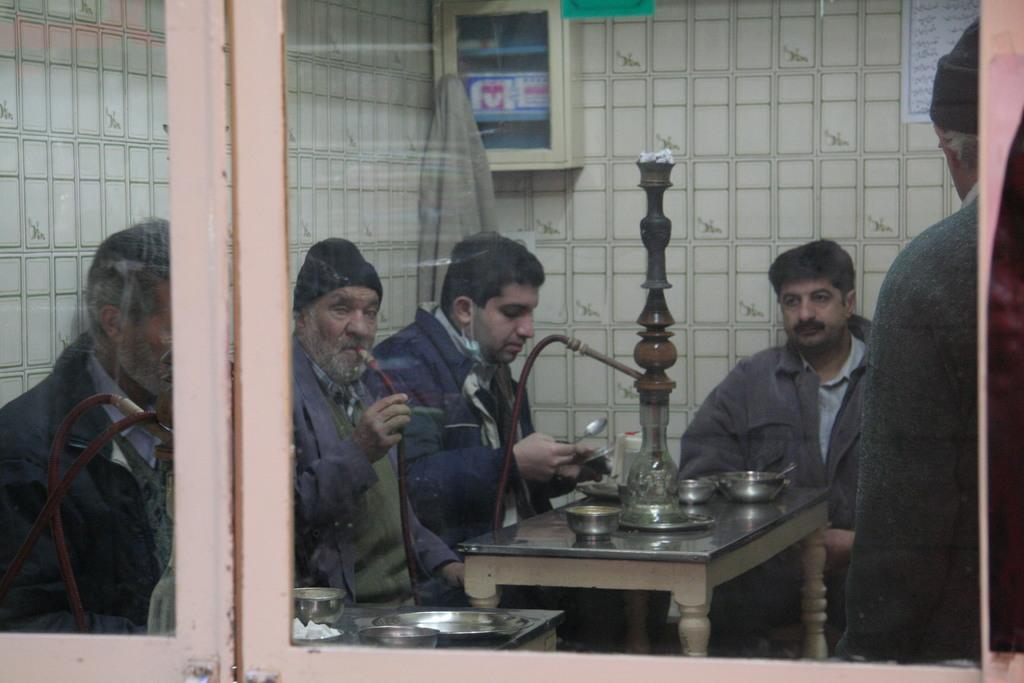What are the people in the image doing? There is a group of people sitting in chairs. What is on the table in front of the group of people? The table has a hookah pot on it. Is there anyone standing in the image? Yes, there is a person standing in the right corner of the image. What type of wren can be seen perched on the hookah pot in the image? There is no wren present in the image; the table has a hookah pot on it, but no birds are visible. 